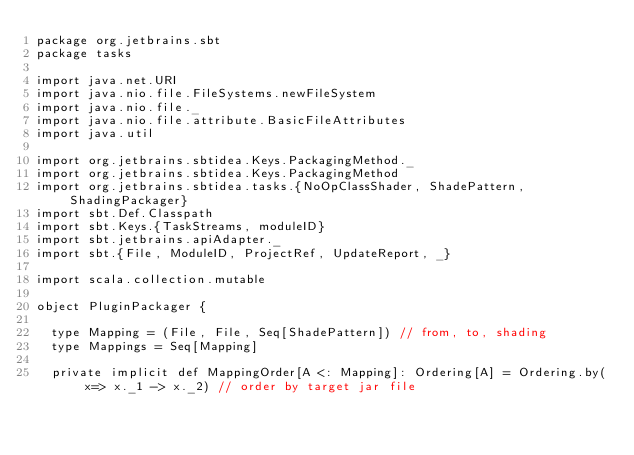Convert code to text. <code><loc_0><loc_0><loc_500><loc_500><_Scala_>package org.jetbrains.sbt
package tasks

import java.net.URI
import java.nio.file.FileSystems.newFileSystem
import java.nio.file._
import java.nio.file.attribute.BasicFileAttributes
import java.util

import org.jetbrains.sbtidea.Keys.PackagingMethod._
import org.jetbrains.sbtidea.Keys.PackagingMethod
import org.jetbrains.sbtidea.tasks.{NoOpClassShader, ShadePattern, ShadingPackager}
import sbt.Def.Classpath
import sbt.Keys.{TaskStreams, moduleID}
import sbt.jetbrains.apiAdapter._
import sbt.{File, ModuleID, ProjectRef, UpdateReport, _}

import scala.collection.mutable

object PluginPackager {

  type Mapping = (File, File, Seq[ShadePattern]) // from, to, shading
  type Mappings = Seq[Mapping]

  private implicit def MappingOrder[A <: Mapping]: Ordering[A] = Ordering.by(x=> x._1 -> x._2) // order by target jar file
</code> 